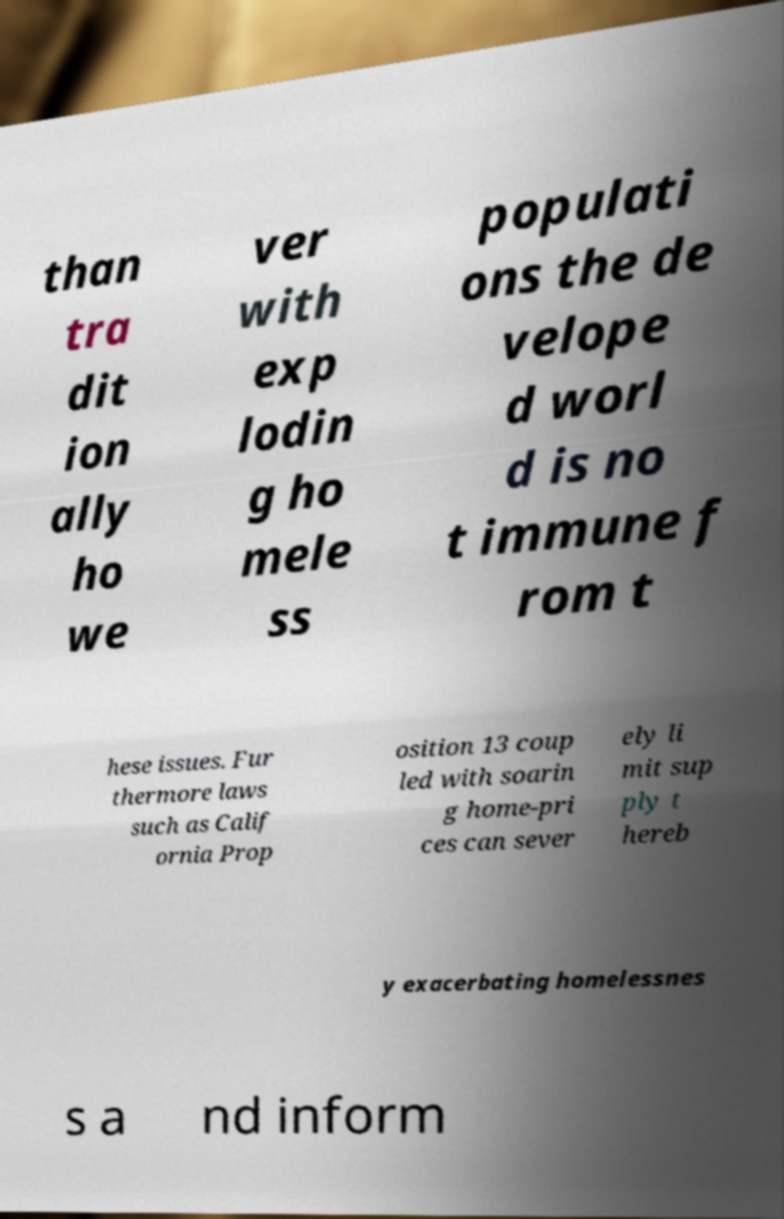What messages or text are displayed in this image? I need them in a readable, typed format. than tra dit ion ally ho we ver with exp lodin g ho mele ss populati ons the de velope d worl d is no t immune f rom t hese issues. Fur thermore laws such as Calif ornia Prop osition 13 coup led with soarin g home-pri ces can sever ely li mit sup ply t hereb y exacerbating homelessnes s a nd inform 